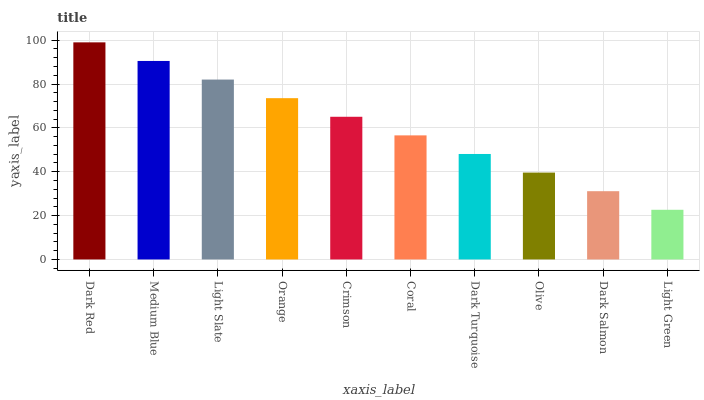Is Medium Blue the minimum?
Answer yes or no. No. Is Medium Blue the maximum?
Answer yes or no. No. Is Dark Red greater than Medium Blue?
Answer yes or no. Yes. Is Medium Blue less than Dark Red?
Answer yes or no. Yes. Is Medium Blue greater than Dark Red?
Answer yes or no. No. Is Dark Red less than Medium Blue?
Answer yes or no. No. Is Crimson the high median?
Answer yes or no. Yes. Is Coral the low median?
Answer yes or no. Yes. Is Orange the high median?
Answer yes or no. No. Is Olive the low median?
Answer yes or no. No. 